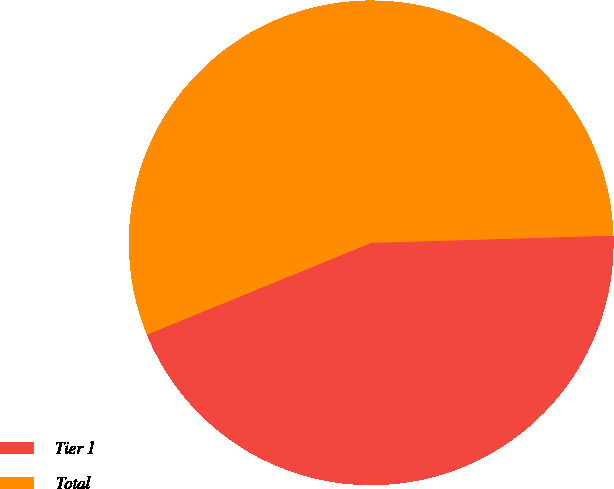Convert chart to OTSL. <chart><loc_0><loc_0><loc_500><loc_500><pie_chart><fcel>Tier 1<fcel>Total<nl><fcel>44.29%<fcel>55.71%<nl></chart> 